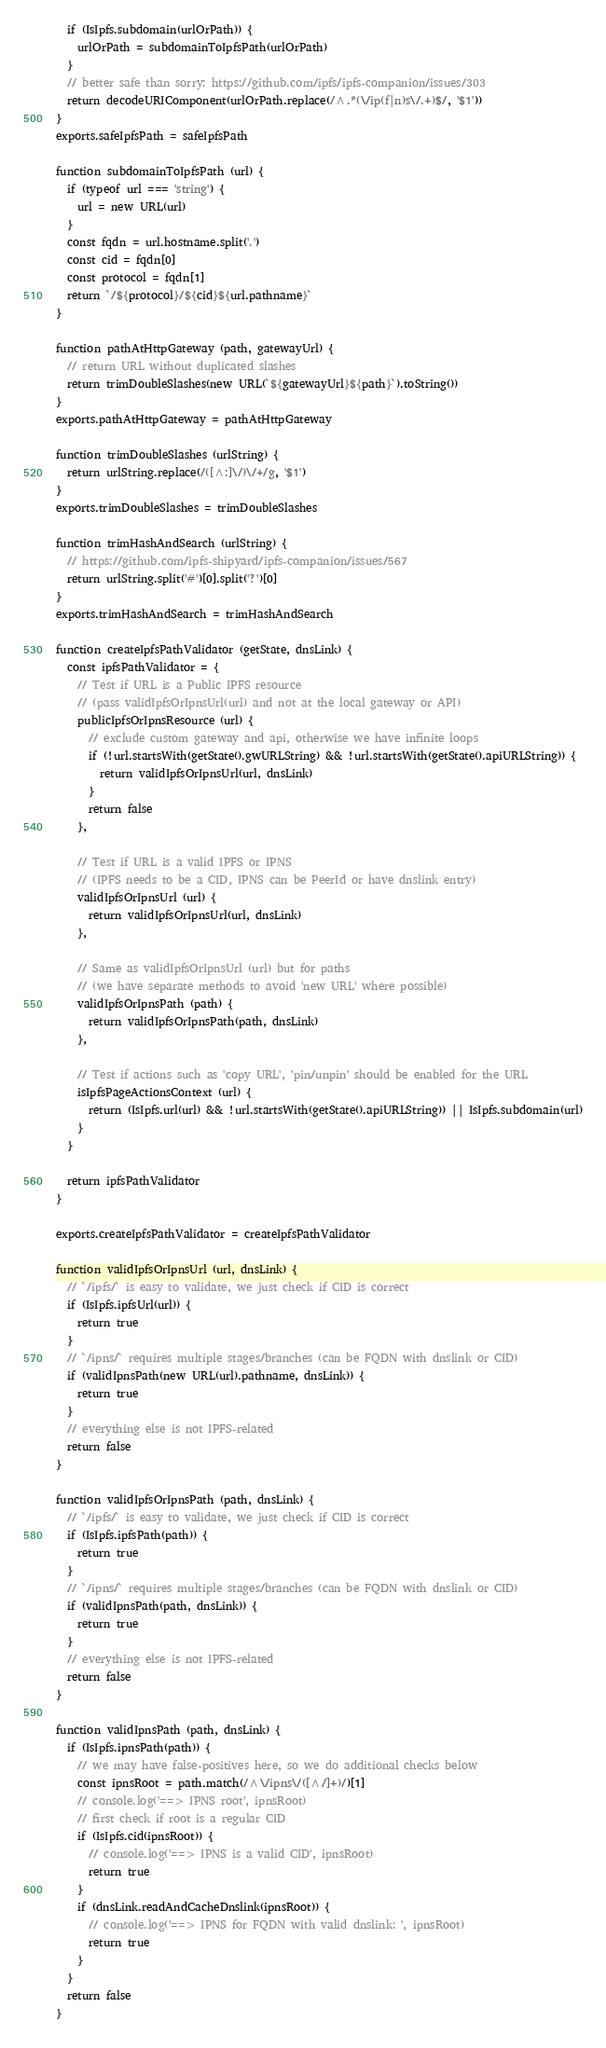<code> <loc_0><loc_0><loc_500><loc_500><_JavaScript_>  if (IsIpfs.subdomain(urlOrPath)) {
    urlOrPath = subdomainToIpfsPath(urlOrPath)
  }
  // better safe than sorry: https://github.com/ipfs/ipfs-companion/issues/303
  return decodeURIComponent(urlOrPath.replace(/^.*(\/ip(f|n)s\/.+)$/, '$1'))
}
exports.safeIpfsPath = safeIpfsPath

function subdomainToIpfsPath (url) {
  if (typeof url === 'string') {
    url = new URL(url)
  }
  const fqdn = url.hostname.split('.')
  const cid = fqdn[0]
  const protocol = fqdn[1]
  return `/${protocol}/${cid}${url.pathname}`
}

function pathAtHttpGateway (path, gatewayUrl) {
  // return URL without duplicated slashes
  return trimDoubleSlashes(new URL(`${gatewayUrl}${path}`).toString())
}
exports.pathAtHttpGateway = pathAtHttpGateway

function trimDoubleSlashes (urlString) {
  return urlString.replace(/([^:]\/)\/+/g, '$1')
}
exports.trimDoubleSlashes = trimDoubleSlashes

function trimHashAndSearch (urlString) {
  // https://github.com/ipfs-shipyard/ipfs-companion/issues/567
  return urlString.split('#')[0].split('?')[0]
}
exports.trimHashAndSearch = trimHashAndSearch

function createIpfsPathValidator (getState, dnsLink) {
  const ipfsPathValidator = {
    // Test if URL is a Public IPFS resource
    // (pass validIpfsOrIpnsUrl(url) and not at the local gateway or API)
    publicIpfsOrIpnsResource (url) {
      // exclude custom gateway and api, otherwise we have infinite loops
      if (!url.startsWith(getState().gwURLString) && !url.startsWith(getState().apiURLString)) {
        return validIpfsOrIpnsUrl(url, dnsLink)
      }
      return false
    },

    // Test if URL is a valid IPFS or IPNS
    // (IPFS needs to be a CID, IPNS can be PeerId or have dnslink entry)
    validIpfsOrIpnsUrl (url) {
      return validIpfsOrIpnsUrl(url, dnsLink)
    },

    // Same as validIpfsOrIpnsUrl (url) but for paths
    // (we have separate methods to avoid 'new URL' where possible)
    validIpfsOrIpnsPath (path) {
      return validIpfsOrIpnsPath(path, dnsLink)
    },

    // Test if actions such as 'copy URL', 'pin/unpin' should be enabled for the URL
    isIpfsPageActionsContext (url) {
      return (IsIpfs.url(url) && !url.startsWith(getState().apiURLString)) || IsIpfs.subdomain(url)
    }
  }

  return ipfsPathValidator
}

exports.createIpfsPathValidator = createIpfsPathValidator

function validIpfsOrIpnsUrl (url, dnsLink) {
  // `/ipfs/` is easy to validate, we just check if CID is correct
  if (IsIpfs.ipfsUrl(url)) {
    return true
  }
  // `/ipns/` requires multiple stages/branches (can be FQDN with dnslink or CID)
  if (validIpnsPath(new URL(url).pathname, dnsLink)) {
    return true
  }
  // everything else is not IPFS-related
  return false
}

function validIpfsOrIpnsPath (path, dnsLink) {
  // `/ipfs/` is easy to validate, we just check if CID is correct
  if (IsIpfs.ipfsPath(path)) {
    return true
  }
  // `/ipns/` requires multiple stages/branches (can be FQDN with dnslink or CID)
  if (validIpnsPath(path, dnsLink)) {
    return true
  }
  // everything else is not IPFS-related
  return false
}

function validIpnsPath (path, dnsLink) {
  if (IsIpfs.ipnsPath(path)) {
    // we may have false-positives here, so we do additional checks below
    const ipnsRoot = path.match(/^\/ipns\/([^/]+)/)[1]
    // console.log('==> IPNS root', ipnsRoot)
    // first check if root is a regular CID
    if (IsIpfs.cid(ipnsRoot)) {
      // console.log('==> IPNS is a valid CID', ipnsRoot)
      return true
    }
    if (dnsLink.readAndCacheDnslink(ipnsRoot)) {
      // console.log('==> IPNS for FQDN with valid dnslink: ', ipnsRoot)
      return true
    }
  }
  return false
}
</code> 